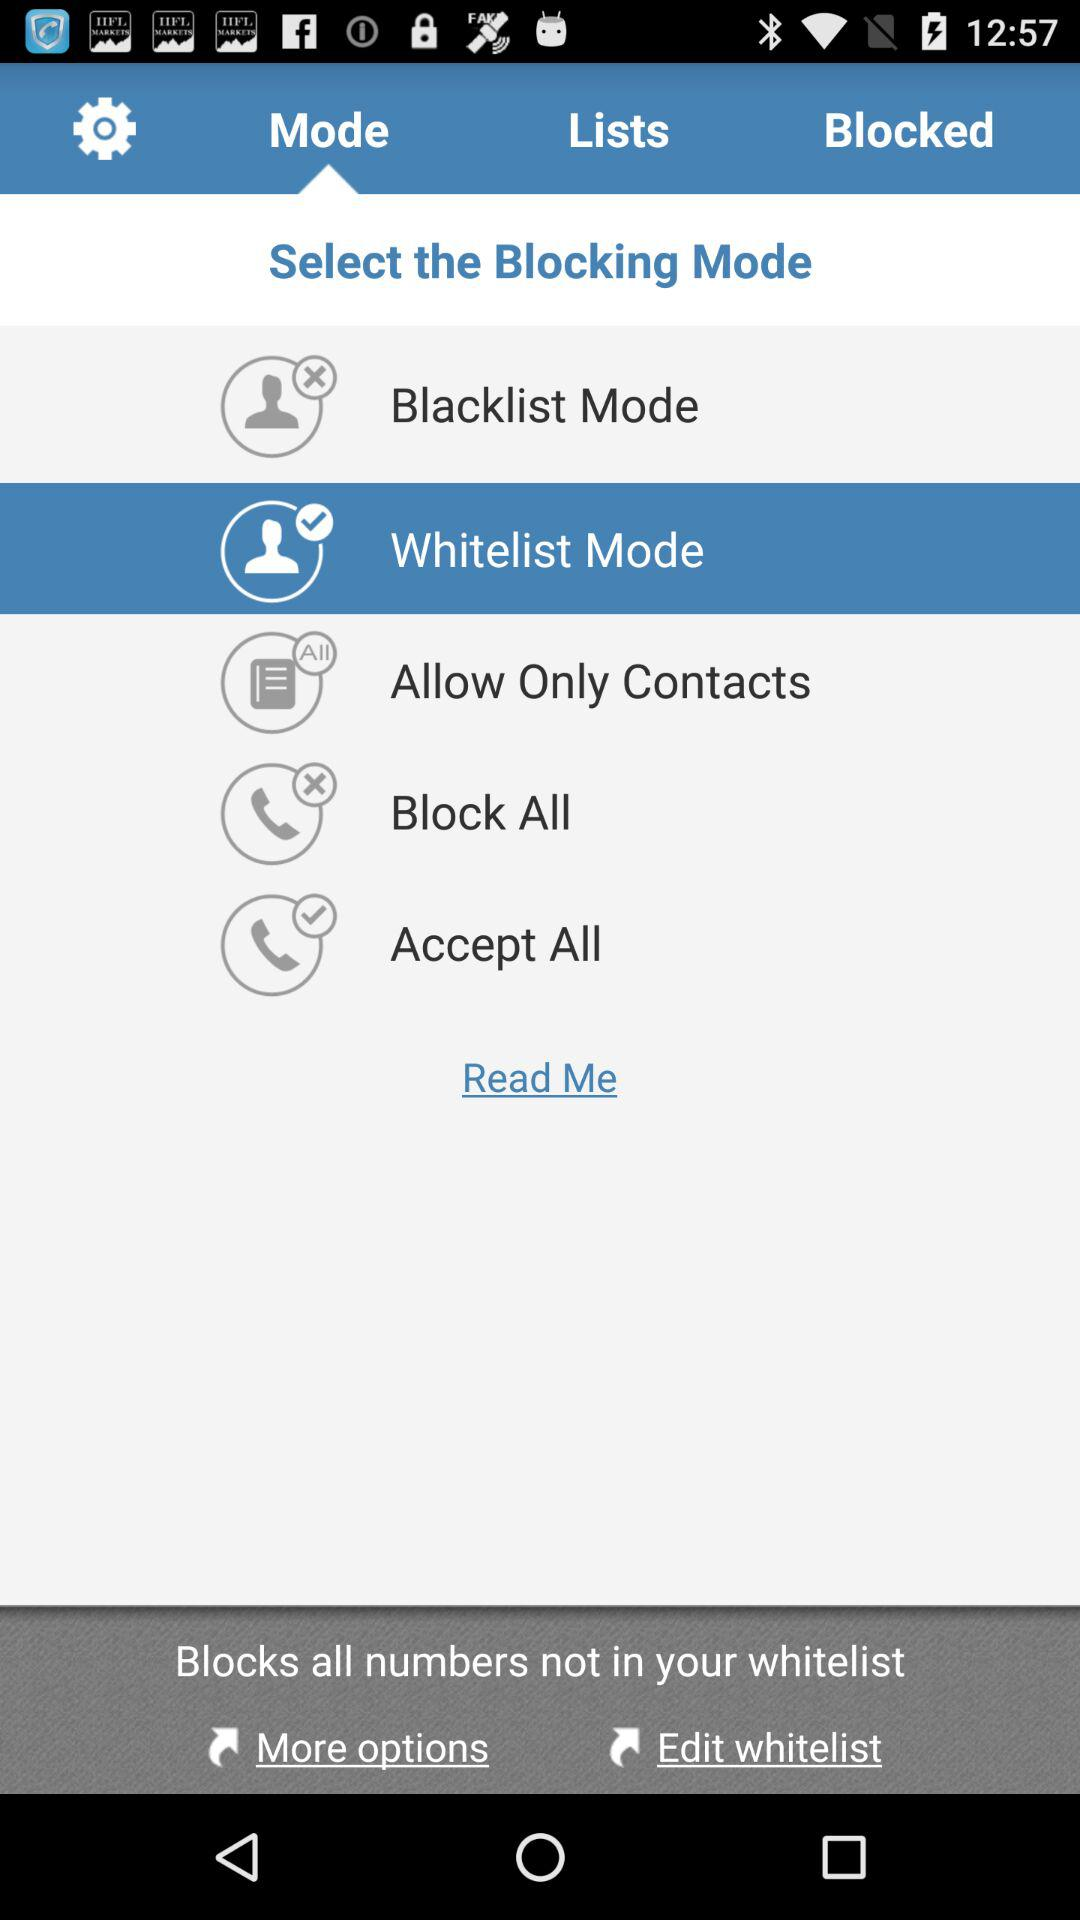Which tab is selected? The selected tab is "Mode". 